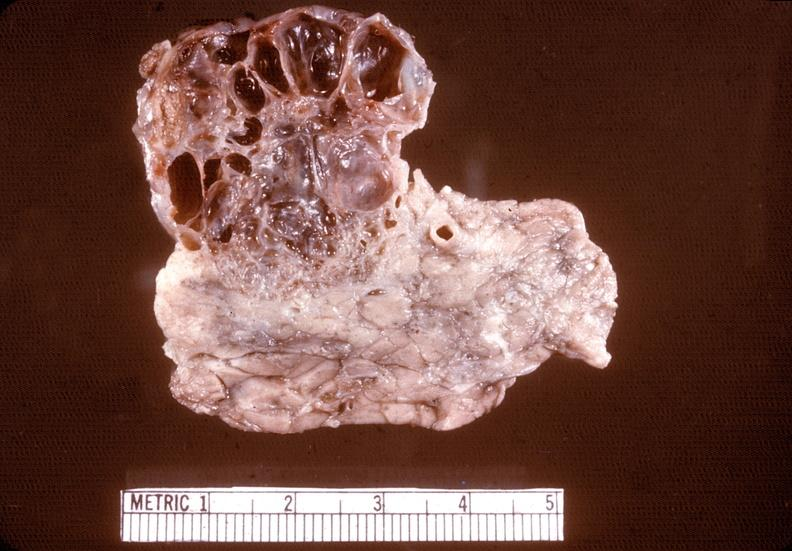what is present?
Answer the question using a single word or phrase. Pancreas 